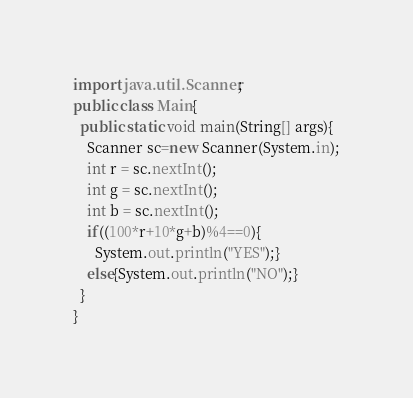<code> <loc_0><loc_0><loc_500><loc_500><_Java_>import java.util.Scanner;
public class Main{
  public static void main(String[] args){
    Scanner sc=new Scanner(System.in);
    int r = sc.nextInt();
    int g = sc.nextInt();
    int b = sc.nextInt();
    if((100*r+10*g+b)%4==0){
      System.out.println("YES");}
    else{System.out.println("NO");}
  }
}
</code> 